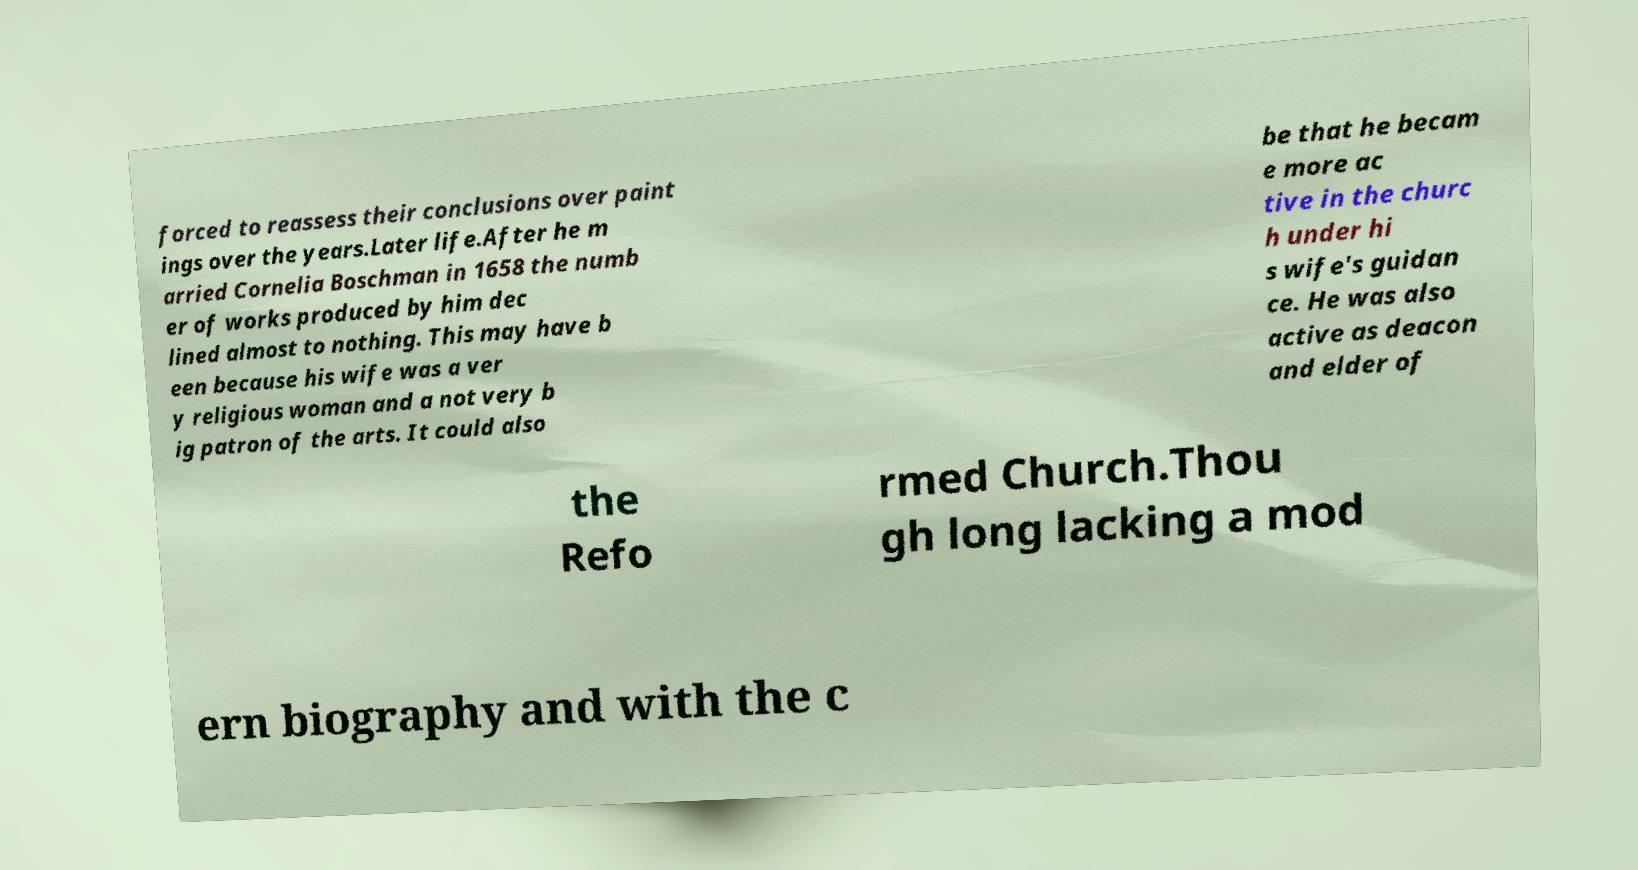I need the written content from this picture converted into text. Can you do that? forced to reassess their conclusions over paint ings over the years.Later life.After he m arried Cornelia Boschman in 1658 the numb er of works produced by him dec lined almost to nothing. This may have b een because his wife was a ver y religious woman and a not very b ig patron of the arts. It could also be that he becam e more ac tive in the churc h under hi s wife's guidan ce. He was also active as deacon and elder of the Refo rmed Church.Thou gh long lacking a mod ern biography and with the c 